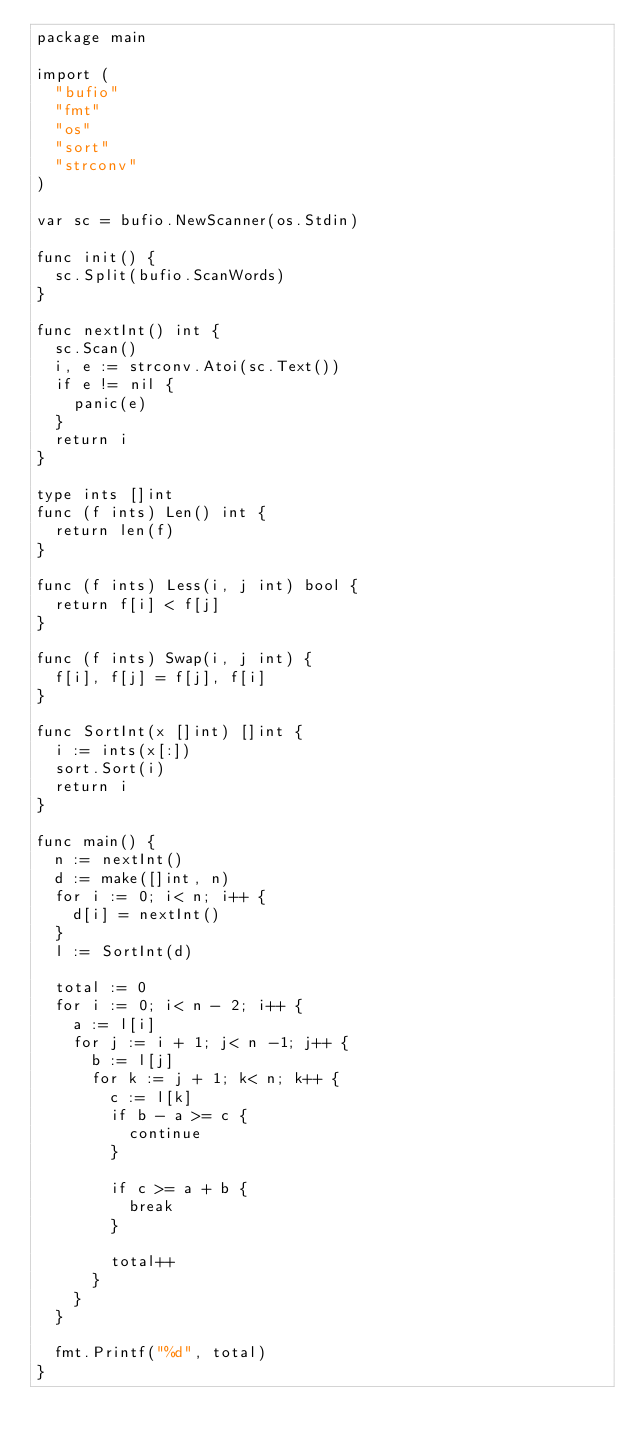Convert code to text. <code><loc_0><loc_0><loc_500><loc_500><_Go_>package main

import (
	"bufio"
	"fmt"
	"os"
	"sort"
	"strconv"
)

var sc = bufio.NewScanner(os.Stdin)

func init() {
	sc.Split(bufio.ScanWords)
}

func nextInt() int {
	sc.Scan()
	i, e := strconv.Atoi(sc.Text())
	if e != nil {
		panic(e)
	}
	return i
}

type ints []int
func (f ints) Len() int {
	return len(f)
}

func (f ints) Less(i, j int) bool {
	return f[i] < f[j]
}

func (f ints) Swap(i, j int) {
	f[i], f[j] = f[j], f[i]
}

func SortInt(x []int) []int {
	i := ints(x[:])
	sort.Sort(i)
	return i
}

func main() {
	n := nextInt()
	d := make([]int, n)
	for i := 0; i< n; i++ {
		d[i] = nextInt()
	}
	l := SortInt(d)

	total := 0
	for i := 0; i< n - 2; i++ {
		a := l[i]
		for j := i + 1; j< n -1; j++ {
			b := l[j]
			for k := j + 1; k< n; k++ {
				c := l[k]
				if b - a >= c {
					continue
				}

				if c >= a + b {
					break
				}

				total++
			}
		}
	}

	fmt.Printf("%d", total)
}
</code> 